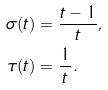Convert formula to latex. <formula><loc_0><loc_0><loc_500><loc_500>\sigma ( t ) & = \frac { t - 1 } { t } , \\ \tau ( t ) & = \frac { 1 } { t } .</formula> 